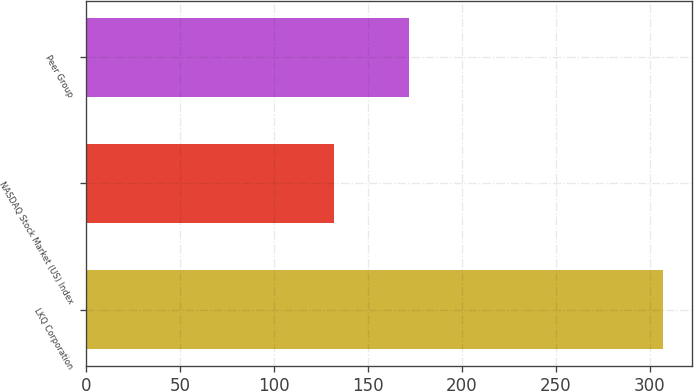<chart> <loc_0><loc_0><loc_500><loc_500><bar_chart><fcel>LKQ Corporation<fcel>NASDAQ Stock Market (US) Index<fcel>Peer Group<nl><fcel>307<fcel>132<fcel>172<nl></chart> 